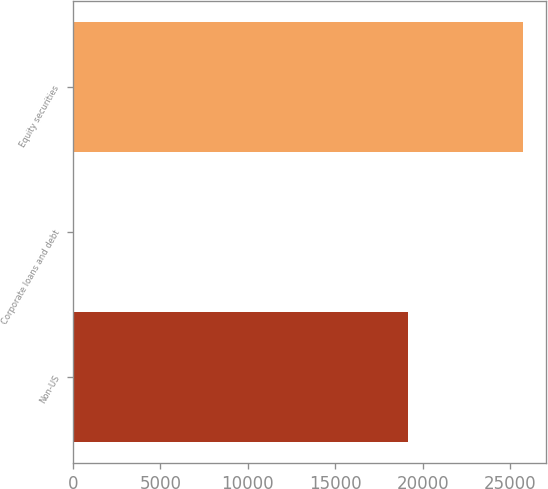Convert chart to OTSL. <chart><loc_0><loc_0><loc_500><loc_500><bar_chart><fcel>Non-US<fcel>Corporate loans and debt<fcel>Equity securities<nl><fcel>19137<fcel>2<fcel>25768<nl></chart> 